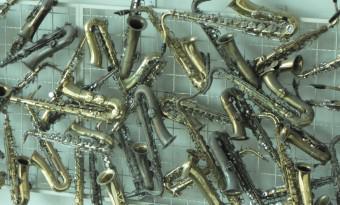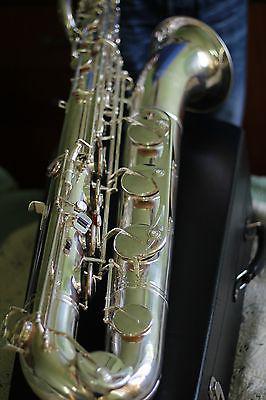The first image is the image on the left, the second image is the image on the right. Examine the images to the left and right. Is the description "A saxophone in one image is positioned inside a dark blue lined case, while a second image shows a section of the gold keys of another saxophone." accurate? Answer yes or no. No. The first image is the image on the left, the second image is the image on the right. Given the left and right images, does the statement "An image shows a saxophone with a mottled finish, displayed in an open plush-lined case." hold true? Answer yes or no. No. 